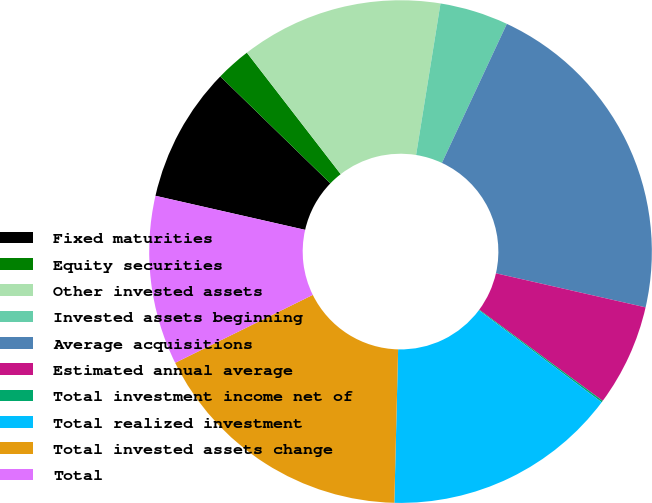Convert chart to OTSL. <chart><loc_0><loc_0><loc_500><loc_500><pie_chart><fcel>Fixed maturities<fcel>Equity securities<fcel>Other invested assets<fcel>Invested assets beginning<fcel>Average acquisitions<fcel>Estimated annual average<fcel>Total investment income net of<fcel>Total realized investment<fcel>Total invested assets change<fcel>Total<nl><fcel>8.71%<fcel>2.26%<fcel>13.01%<fcel>4.41%<fcel>21.61%<fcel>6.56%<fcel>0.11%<fcel>15.16%<fcel>17.31%<fcel>10.86%<nl></chart> 